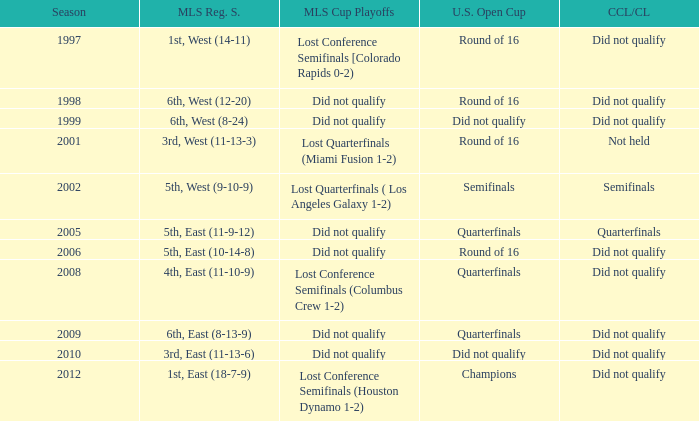Give me the full table as a dictionary. {'header': ['Season', 'MLS Reg. S.', 'MLS Cup Playoffs', 'U.S. Open Cup', 'CCL/CL'], 'rows': [['1997', '1st, West (14-11)', 'Lost Conference Semifinals [Colorado Rapids 0-2)', 'Round of 16', 'Did not qualify'], ['1998', '6th, West (12-20)', 'Did not qualify', 'Round of 16', 'Did not qualify'], ['1999', '6th, West (8-24)', 'Did not qualify', 'Did not qualify', 'Did not qualify'], ['2001', '3rd, West (11-13-3)', 'Lost Quarterfinals (Miami Fusion 1-2)', 'Round of 16', 'Not held'], ['2002', '5th, West (9-10-9)', 'Lost Quarterfinals ( Los Angeles Galaxy 1-2)', 'Semifinals', 'Semifinals'], ['2005', '5th, East (11-9-12)', 'Did not qualify', 'Quarterfinals', 'Quarterfinals'], ['2006', '5th, East (10-14-8)', 'Did not qualify', 'Round of 16', 'Did not qualify'], ['2008', '4th, East (11-10-9)', 'Lost Conference Semifinals (Columbus Crew 1-2)', 'Quarterfinals', 'Did not qualify'], ['2009', '6th, East (8-13-9)', 'Did not qualify', 'Quarterfinals', 'Did not qualify'], ['2010', '3rd, East (11-13-6)', 'Did not qualify', 'Did not qualify', 'Did not qualify'], ['2012', '1st, East (18-7-9)', 'Lost Conference Semifinals (Houston Dynamo 1-2)', 'Champions', 'Did not qualify']]} What were the placements of the team in regular season when they reached quarterfinals in the U.S. Open Cup but did not qualify for the Concaf Champions Cup? 4th, East (11-10-9), 6th, East (8-13-9). 